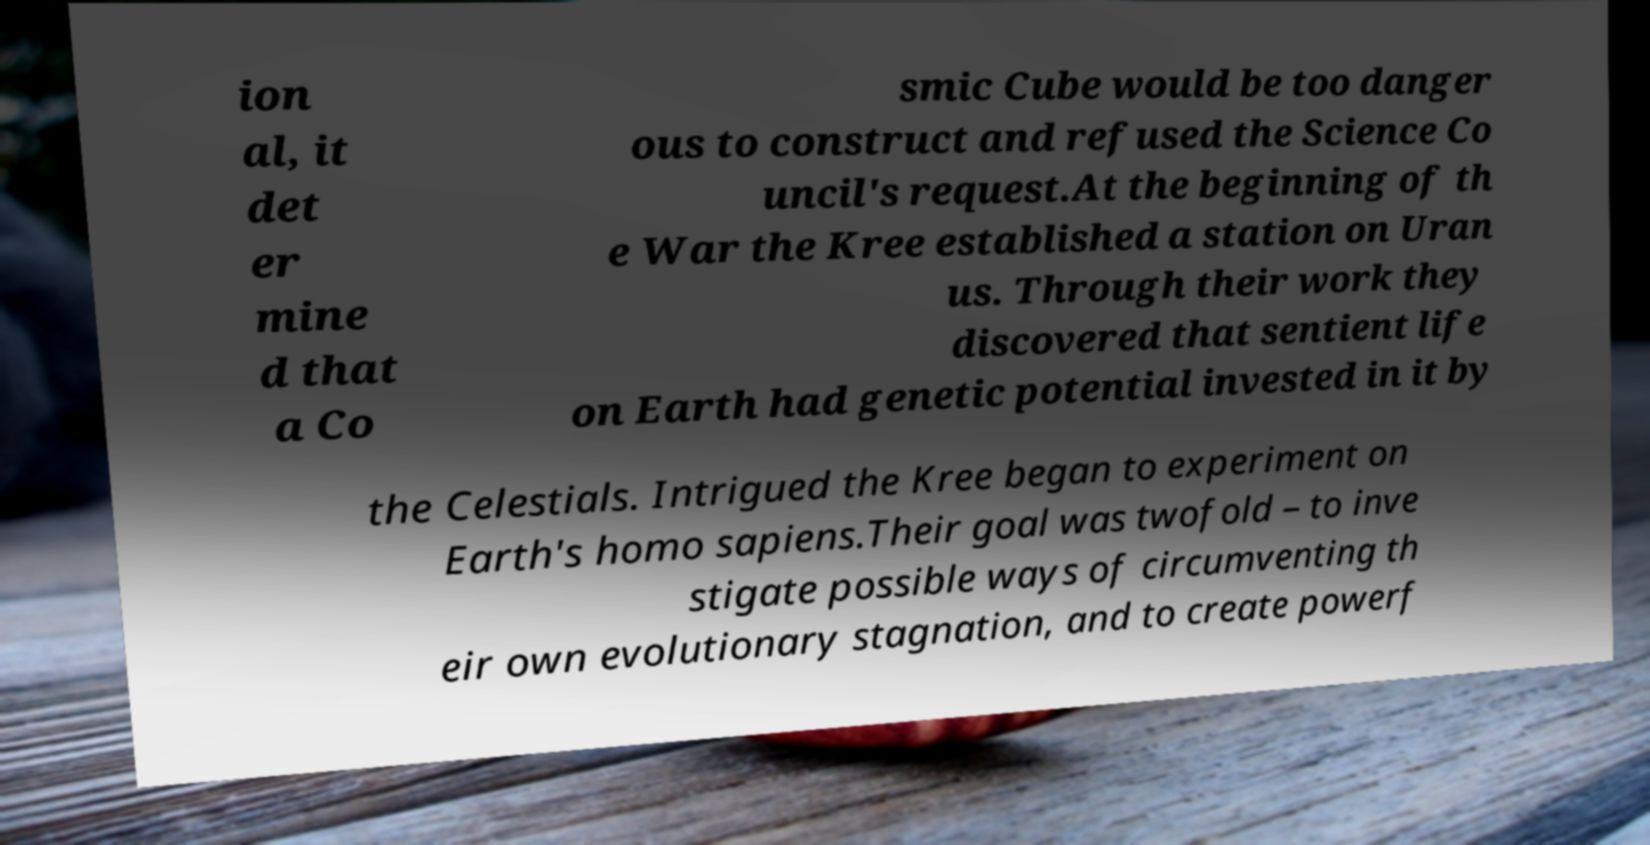Can you accurately transcribe the text from the provided image for me? ion al, it det er mine d that a Co smic Cube would be too danger ous to construct and refused the Science Co uncil's request.At the beginning of th e War the Kree established a station on Uran us. Through their work they discovered that sentient life on Earth had genetic potential invested in it by the Celestials. Intrigued the Kree began to experiment on Earth's homo sapiens.Their goal was twofold – to inve stigate possible ways of circumventing th eir own evolutionary stagnation, and to create powerf 